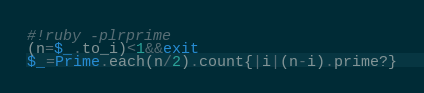<code> <loc_0><loc_0><loc_500><loc_500><_Ruby_>#!ruby -plrprime
(n=$_.to_i)<1&&exit
$_=Prime.each(n/2).count{|i|(n-i).prime?}</code> 